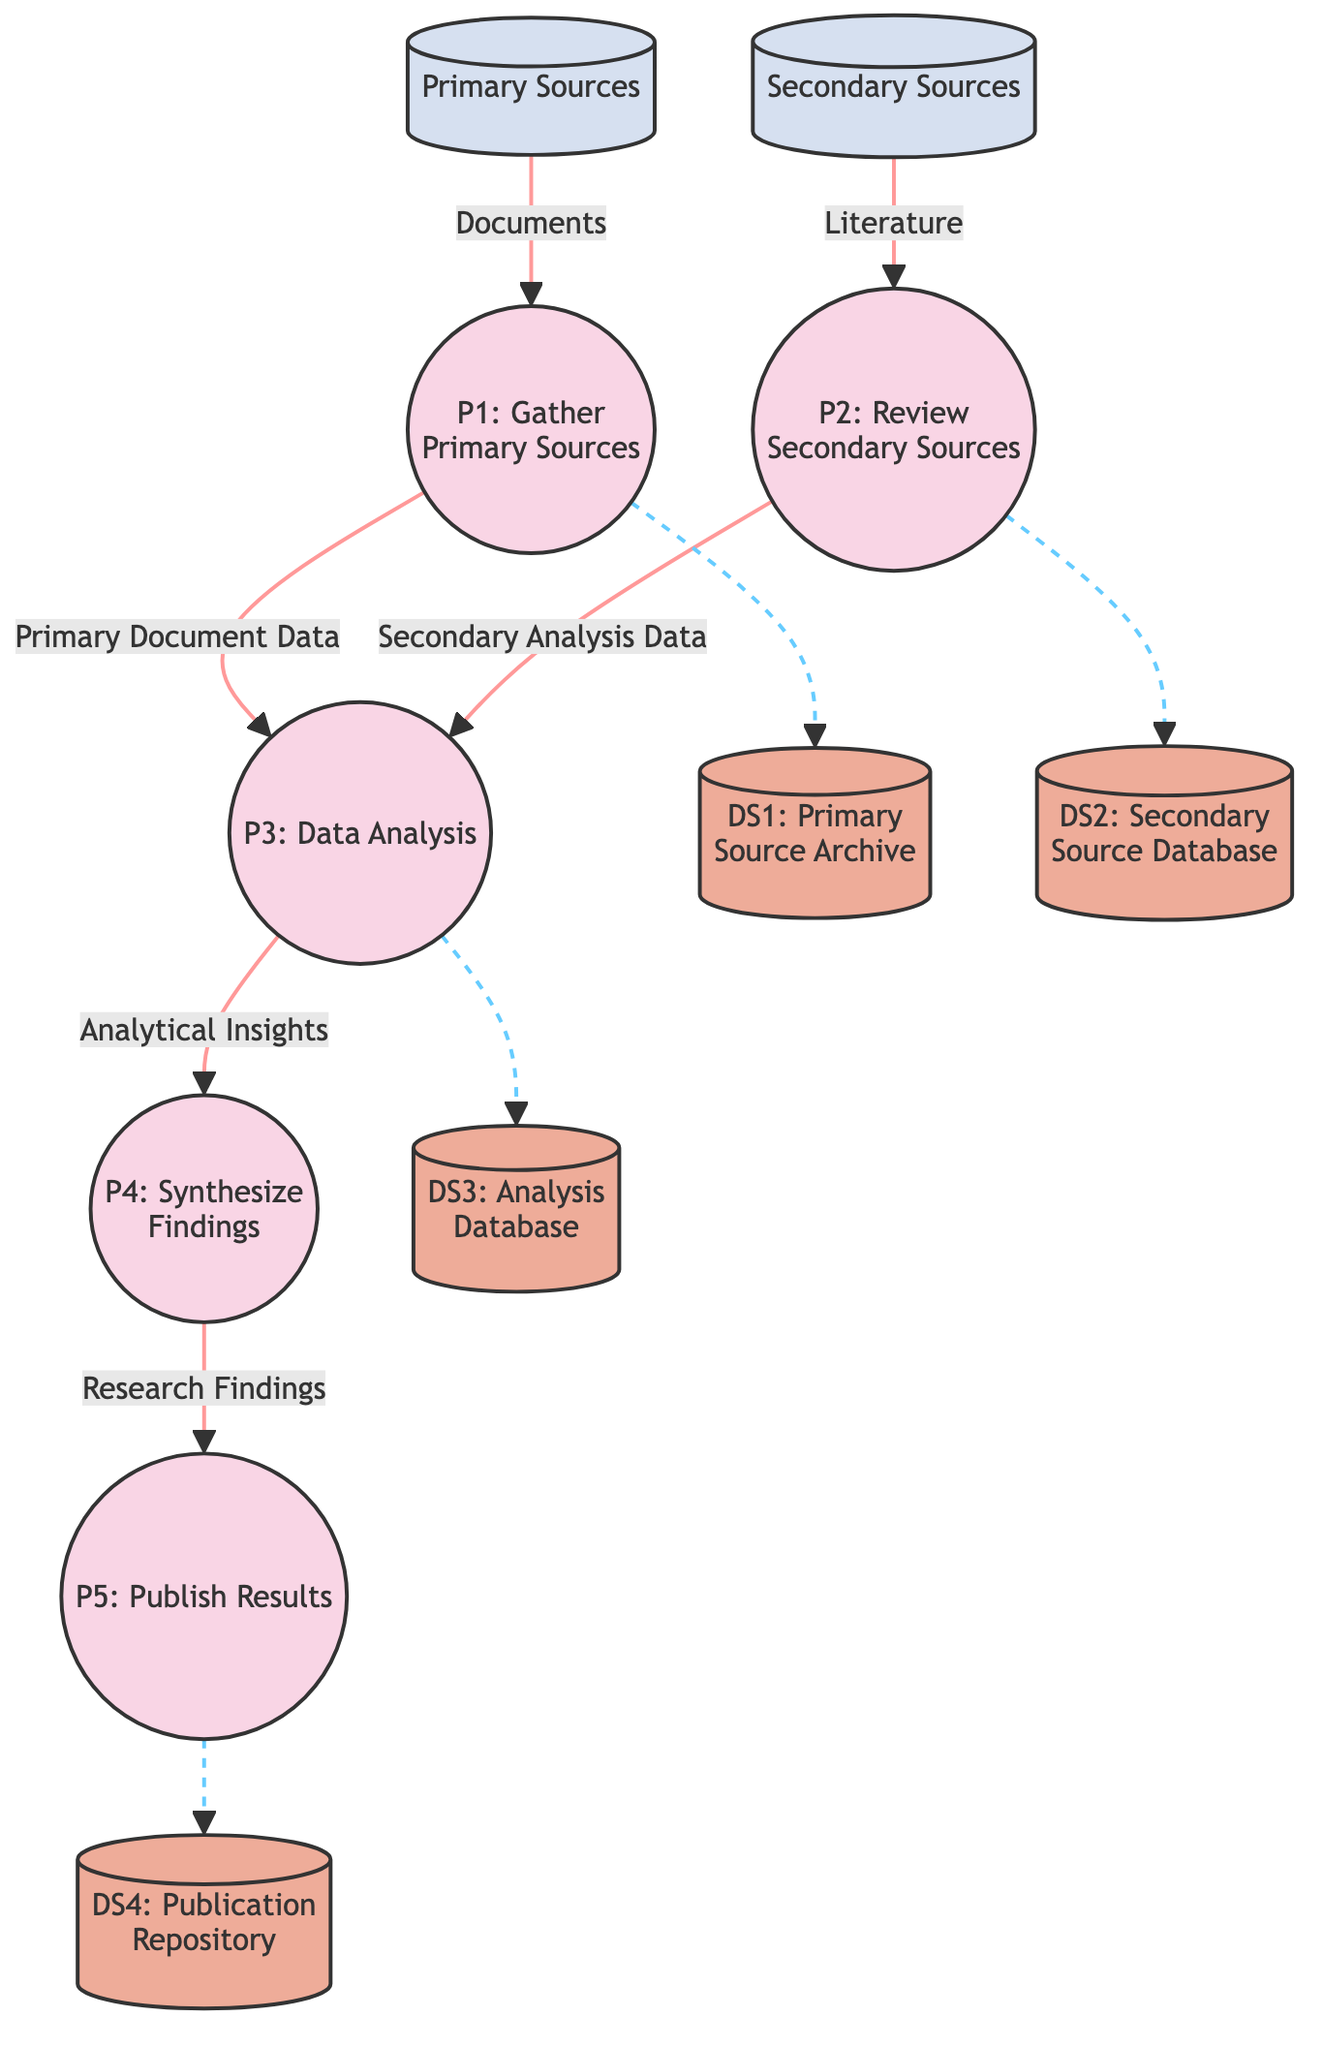What are the primary sources in this diagram? The diagram indicates "Primary Sources" as an external entity that provides documents for the process of gathering primary sources.
Answer: Primary Sources How many processes are present in the diagram? By visually counting, there are five distinct processes outlined: Gathering Primary Sources, Reviewing Secondary Sources, Data Analysis, Synthesizing Findings, and Publishing Results.
Answer: 5 What is the data flow from the gathering of primary sources? The flow starts from "Primary Sources," where documents are collected and directed into the "Gather Primary Sources" process, which then sends "Primary Document Data" to the "Data Analysis" process.
Answer: Primary Document Data Which process synthesizes findings? The process that synthesizes findings is labeled "P4: Synthesize Findings," which integrates insights from previous processes.
Answer: P4: Synthesize Findings What type of data is stored in the Analysis Database? The Analysis Database is designated for storing intermediate analytical data that arises from both primary and secondary sources, as indicated by the data flow connections.
Answer: Analytical Data How does secondary source literature influence data analysis? The secondary source literature is reviewed in the "Review Secondary Sources" process and then flows into the "Data Analysis" process, influencing it with "Secondary Analysis Data."
Answer: Secondary Analysis Data Which process publishes research findings? The diagram clearly indicates that the "Publish Results" process, known as "P5," is responsible for documenting and disseminating the research findings.
Answer: P5: Publish Results What are the contents of the Publication Repository? The Publication Repository houses the finalized research findings that have been completed in the "Publish Results" process.
Answer: Research Findings Which data stores are not directly connected to any of the processing flows? The primary and secondary source archives (DS1 and DS2) are shown as repositories where data is not flowed into the processing steps but serves as sources for initial data gathering.
Answer: DS1 and DS2 